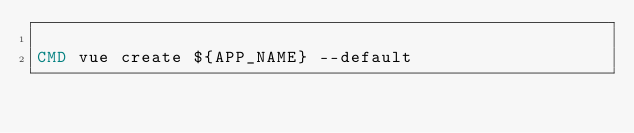Convert code to text. <code><loc_0><loc_0><loc_500><loc_500><_Dockerfile_>
CMD vue create ${APP_NAME} --default
</code> 